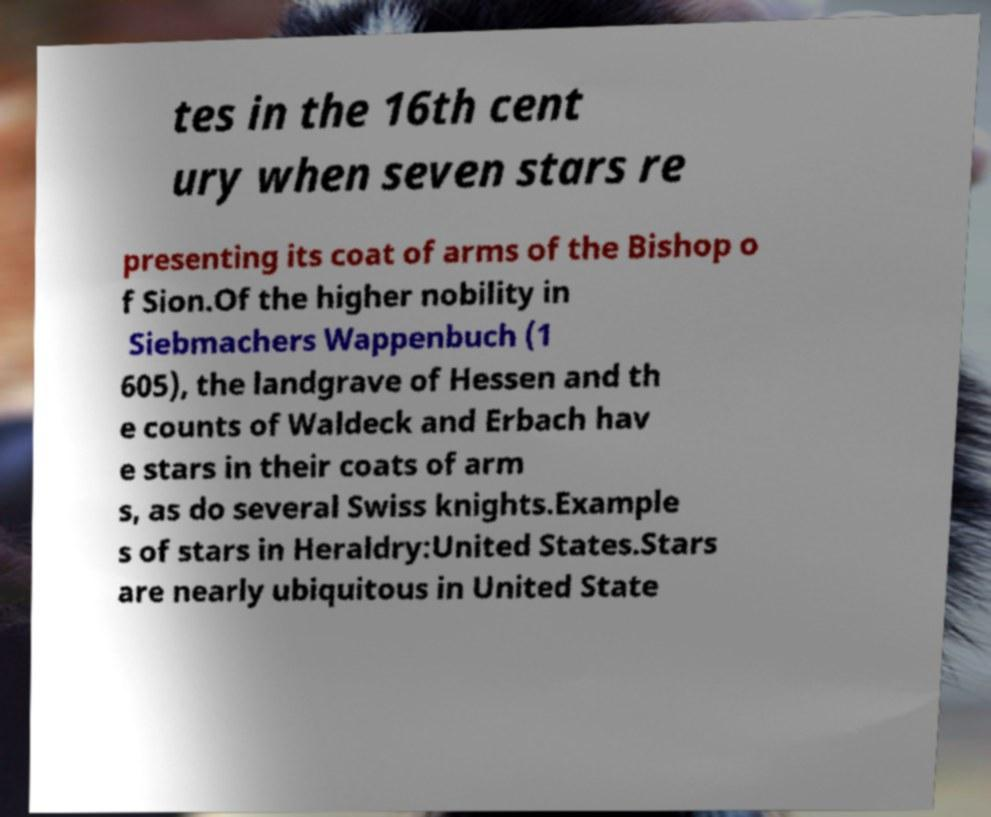What messages or text are displayed in this image? I need them in a readable, typed format. tes in the 16th cent ury when seven stars re presenting its coat of arms of the Bishop o f Sion.Of the higher nobility in Siebmachers Wappenbuch (1 605), the landgrave of Hessen and th e counts of Waldeck and Erbach hav e stars in their coats of arm s, as do several Swiss knights.Example s of stars in Heraldry:United States.Stars are nearly ubiquitous in United State 